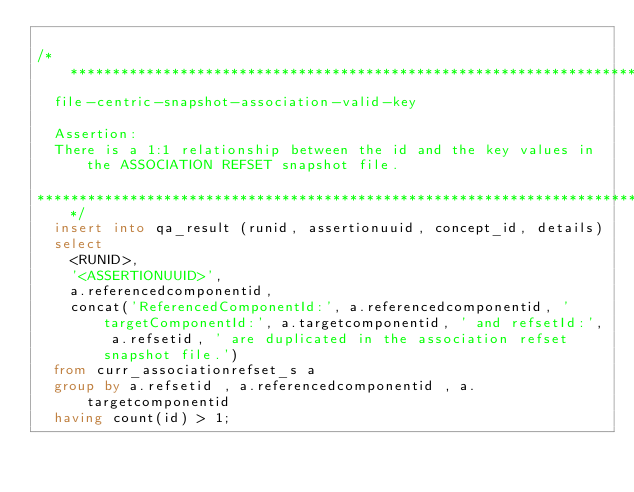<code> <loc_0><loc_0><loc_500><loc_500><_SQL_>
/******************************************************************************** 
	file-centric-snapshot-association-valid-key

	Assertion:
	There is a 1:1 relationship between the id and the key values in the ASSOCIATION REFSET snapshot file.

********************************************************************************/
	insert into qa_result (runid, assertionuuid, concept_id, details)
	select 
		<RUNID>,
		'<ASSERTIONUUID>',
		a.referencedcomponentid,
		concat('ReferencedComponentId:', a.referencedcomponentid, ' targetComponentId:', a.targetcomponentid, ' and refsetId:', a.refsetid, ' are duplicated in the association refset snapshot file.') 	
	from curr_associationrefset_s a 
	group by a.refsetid , a.referencedcomponentid , a.targetcomponentid
	having count(id) > 1;
	
	</code> 